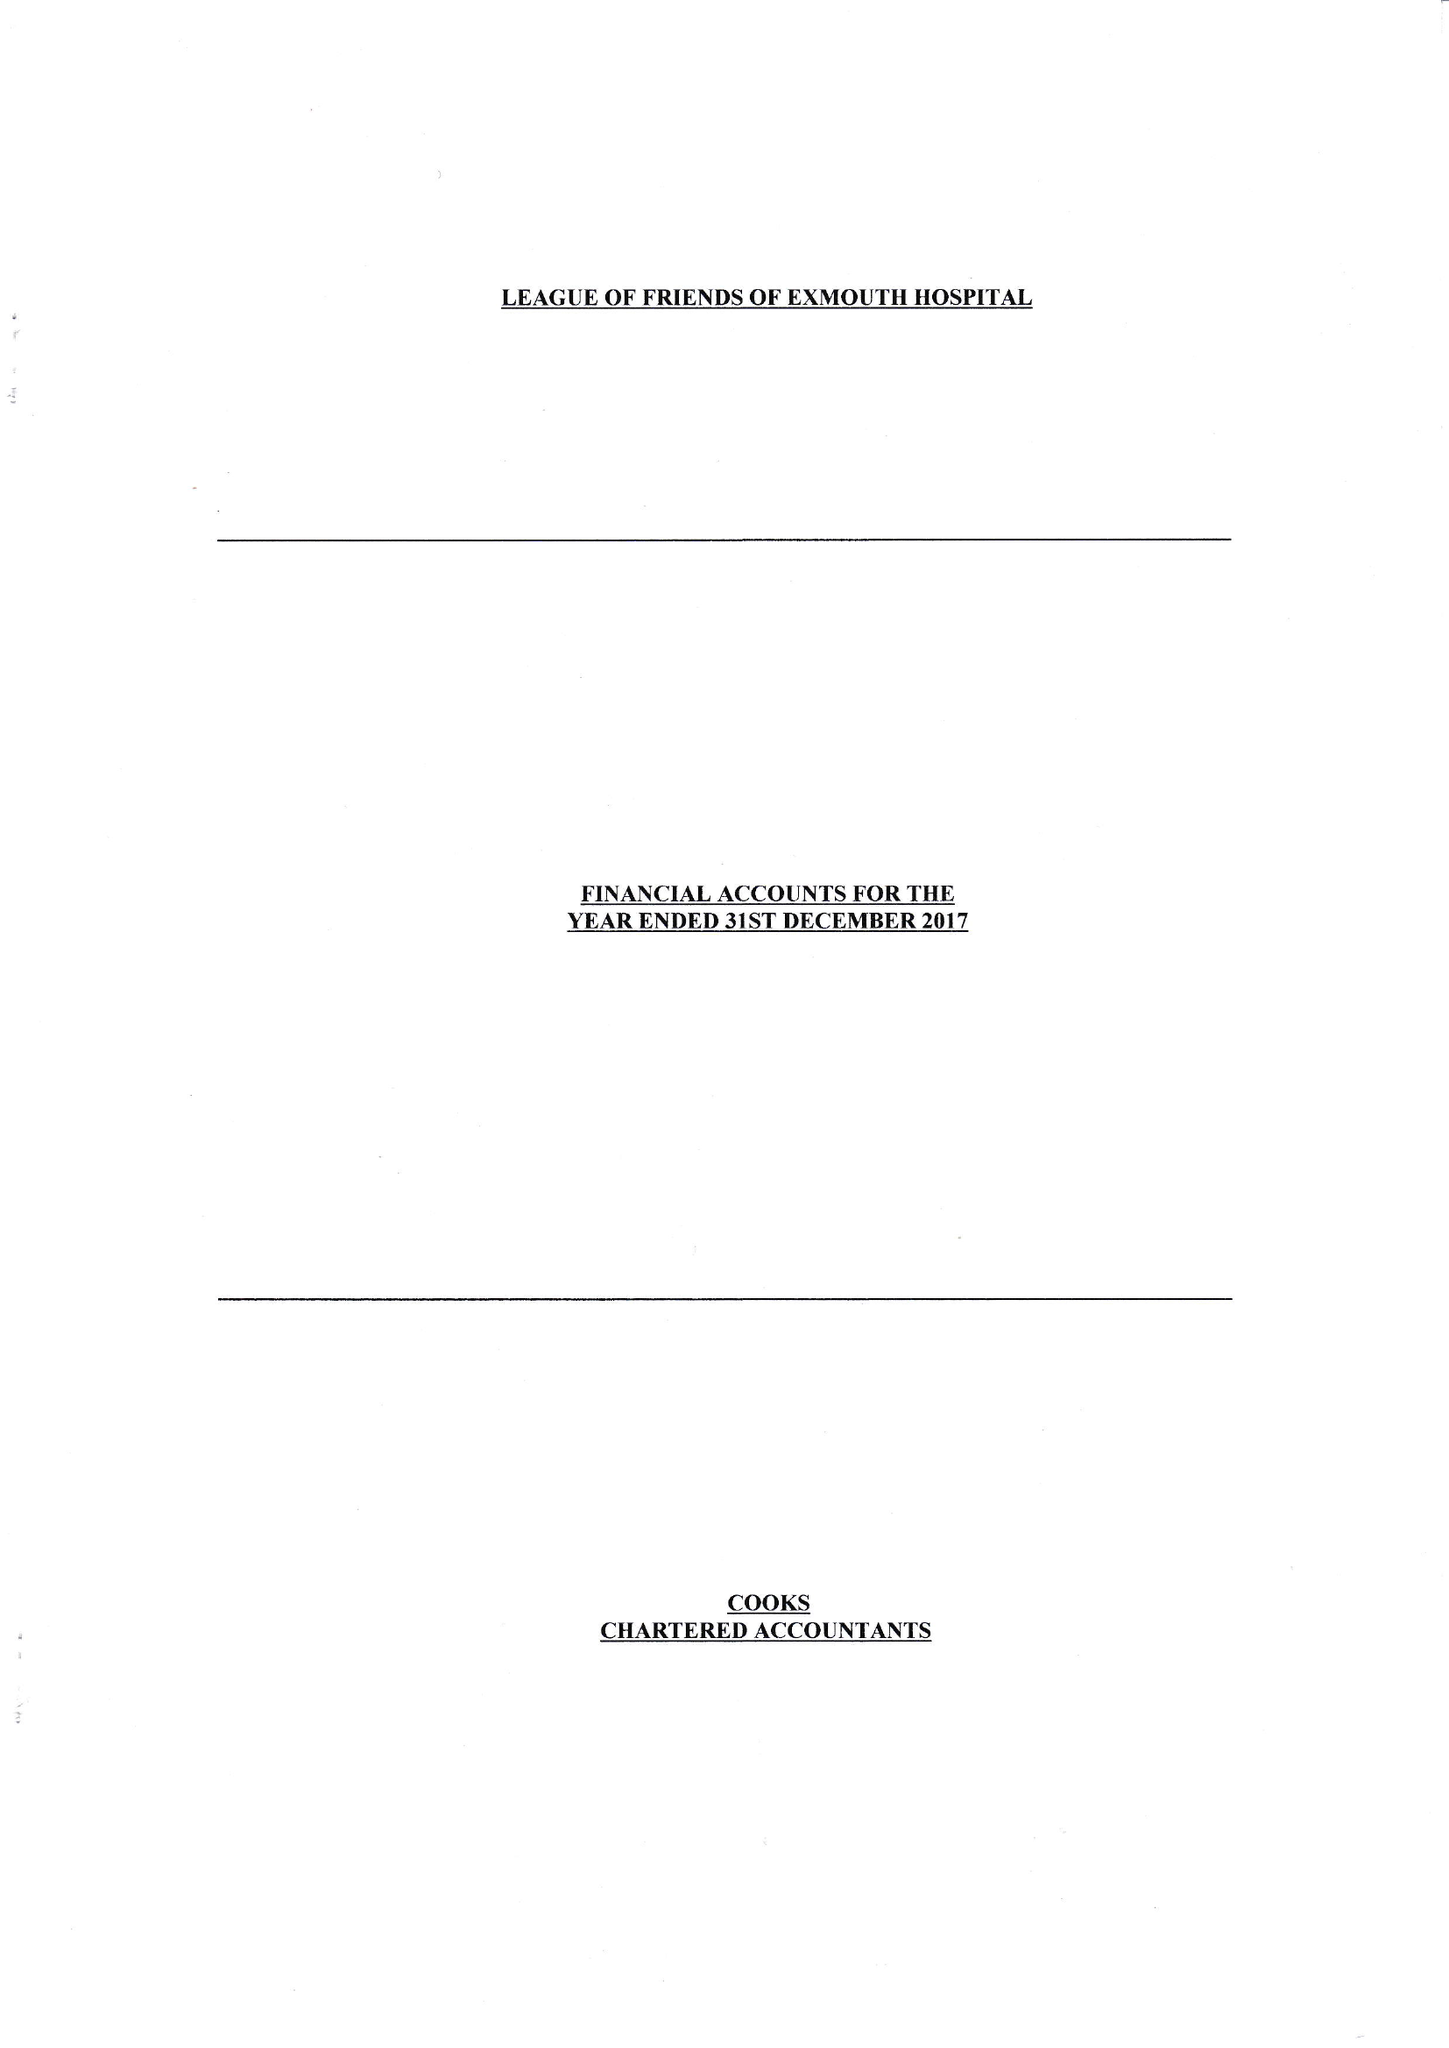What is the value for the charity_number?
Answer the question using a single word or phrase. 254353 